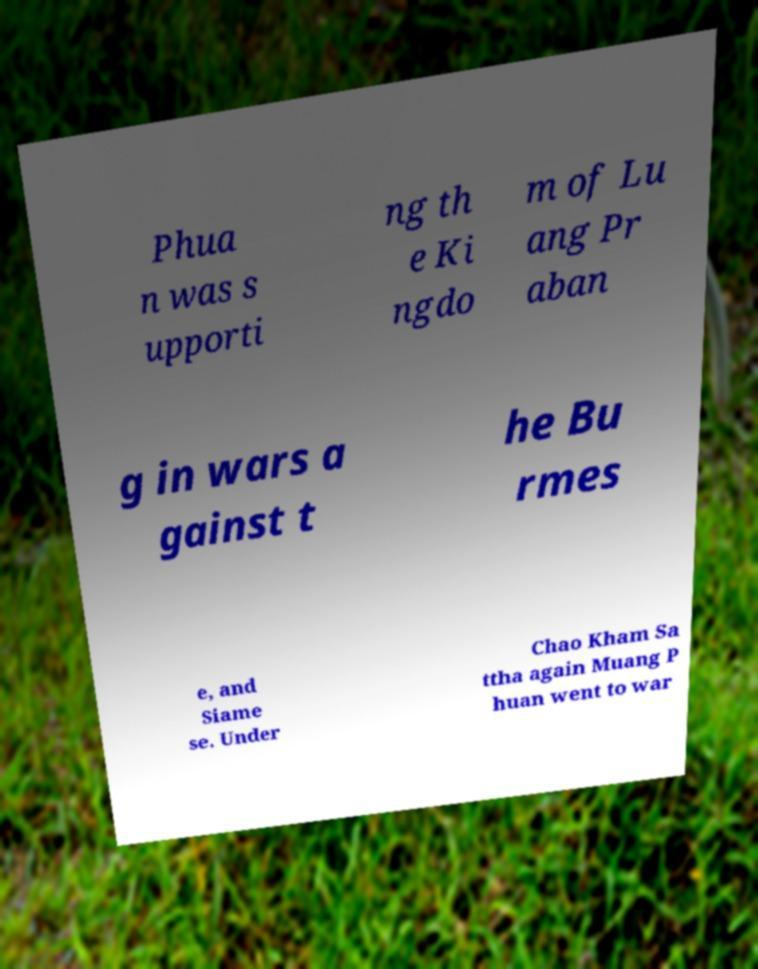For documentation purposes, I need the text within this image transcribed. Could you provide that? Phua n was s upporti ng th e Ki ngdo m of Lu ang Pr aban g in wars a gainst t he Bu rmes e, and Siame se. Under Chao Kham Sa ttha again Muang P huan went to war 